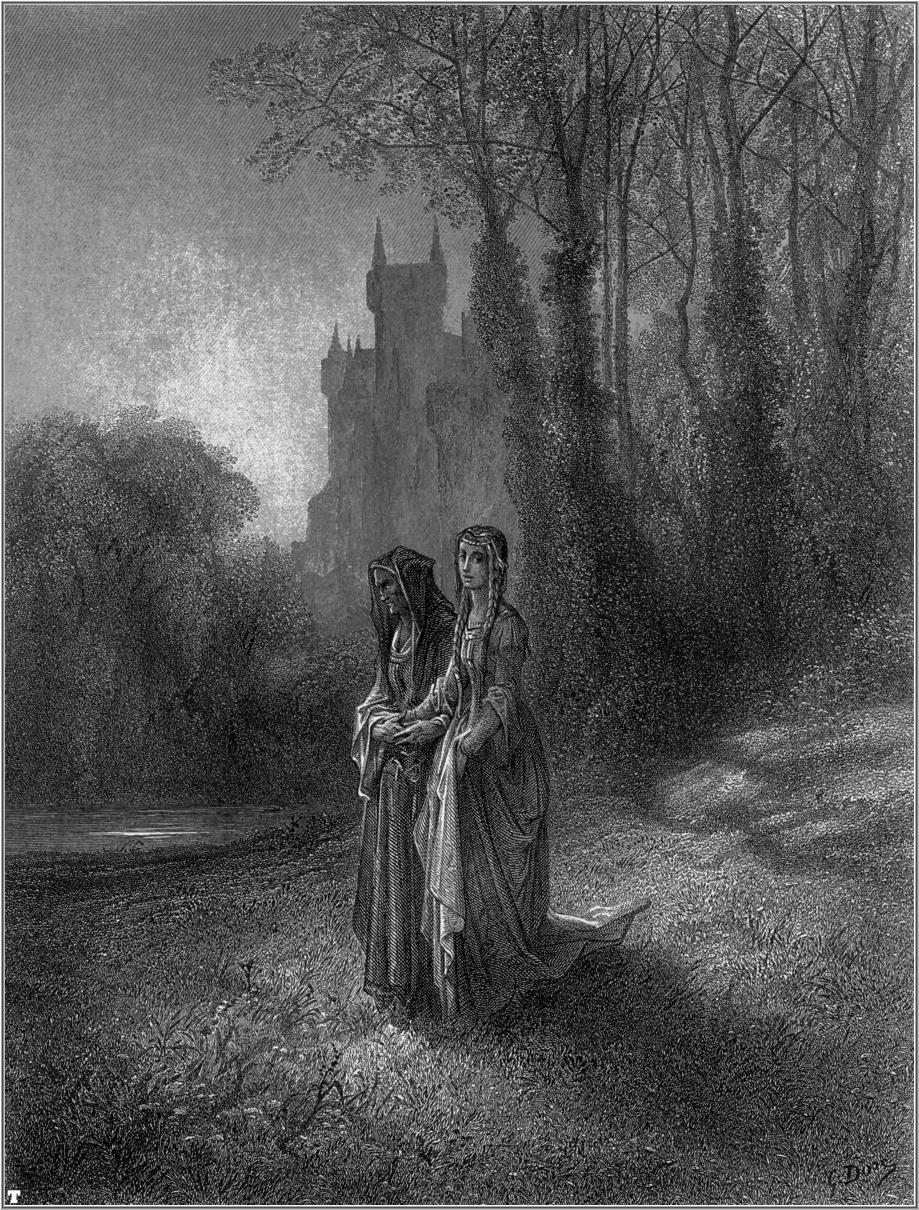If you could add a fantastical creature in the scene, what would it be and why? Imagine a magnificent, ethereal unicorn emerging from behind the trees. The unicorn's shimmering coat glistens in the soft light, and its spiraled horn appears almost luminescent against the misty backdrop. This magical creature symbolizes purity, grace, and the untouched beauty of the forest. The presence of the unicorn adds an enchanting layer to the illustration, evoking a sense of wonder and hinting at a mythical connection between the natural world and the two women. Its gentle gaze and composed demeanor would complement the tranquil atmosphere and elevate the scene into the realm of fairy tales and legends. 